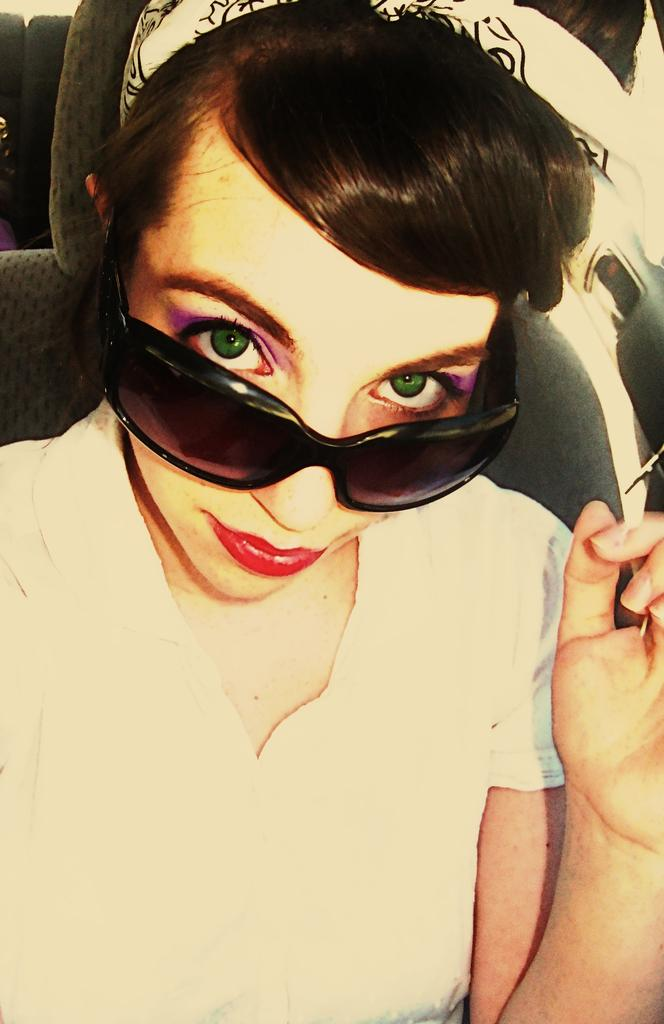Who is the main subject in the image? There is a lady in the image. What is the lady wearing? The lady is wearing spectacles. What is the lady doing in the image? The lady is sitting. What can be seen on the right side of the image? There is a black colored object on the right side of the image. How many legs does the lady have in the image? The lady has two legs, but this question is irrelevant to the image as it does not focus on the number of legs. 